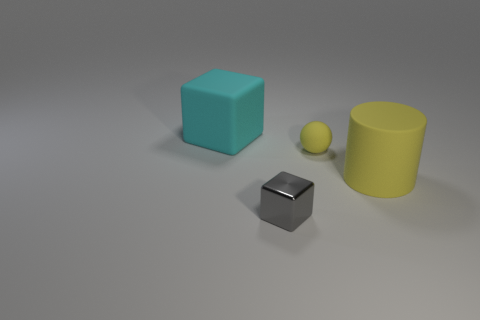Is the material of the cube behind the big yellow matte cylinder the same as the large thing in front of the big cyan thing?
Offer a terse response. Yes. How many spheres are either gray shiny objects or small red things?
Your response must be concise. 0. There is a block that is behind the big object to the right of the big rubber cube; what number of big things are in front of it?
Keep it short and to the point. 1. There is a tiny gray object that is the same shape as the large cyan thing; what material is it?
Your response must be concise. Metal. Is there anything else that has the same material as the small yellow object?
Make the answer very short. Yes. What color is the cube on the right side of the matte cube?
Give a very brief answer. Gray. Is the material of the big cyan cube the same as the large thing that is to the right of the small matte sphere?
Your response must be concise. Yes. What material is the tiny yellow ball?
Provide a short and direct response. Rubber. The big yellow thing that is the same material as the yellow sphere is what shape?
Offer a very short reply. Cylinder. What number of other objects are there of the same shape as the cyan rubber thing?
Provide a succinct answer. 1. 